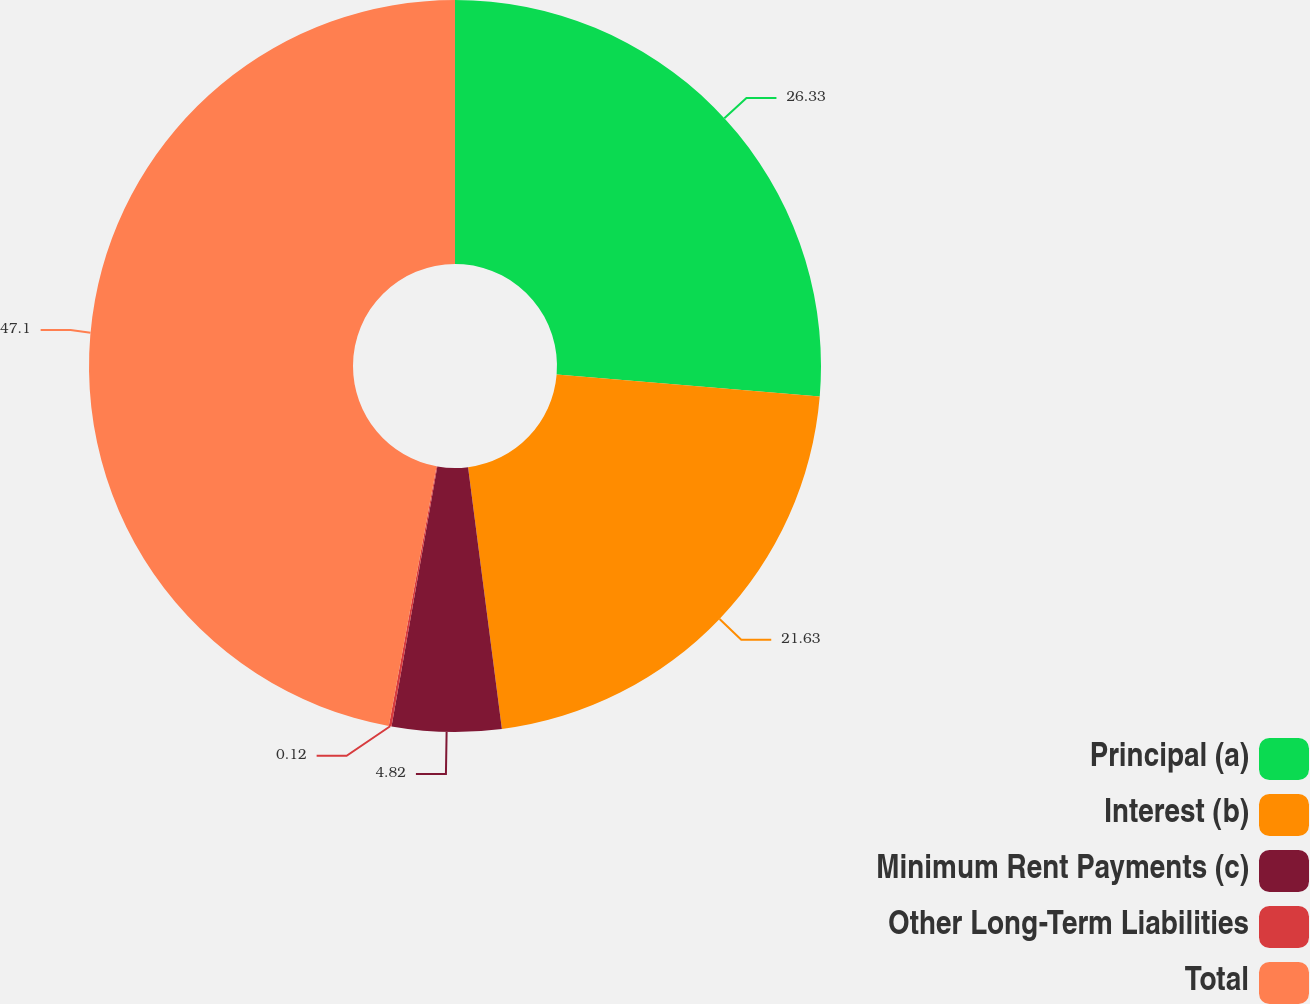Convert chart. <chart><loc_0><loc_0><loc_500><loc_500><pie_chart><fcel>Principal (a)<fcel>Interest (b)<fcel>Minimum Rent Payments (c)<fcel>Other Long-Term Liabilities<fcel>Total<nl><fcel>26.33%<fcel>21.63%<fcel>4.82%<fcel>0.12%<fcel>47.11%<nl></chart> 